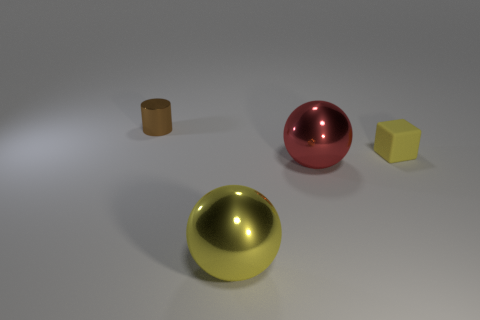Is the number of shiny objects to the left of the tiny brown metallic cylinder less than the number of big gray shiny balls?
Offer a terse response. No. There is a shiny sphere that is the same size as the red shiny thing; what color is it?
Ensure brevity in your answer.  Yellow. How many red things have the same shape as the tiny brown thing?
Your answer should be compact. 0. There is a small thing that is in front of the brown shiny cylinder; what color is it?
Give a very brief answer. Yellow. How many matte objects are either small gray cylinders or red objects?
Offer a very short reply. 0. There is a large metal thing that is the same color as the matte thing; what shape is it?
Make the answer very short. Sphere. What number of gray matte spheres have the same size as the metallic cylinder?
Make the answer very short. 0. There is a thing that is both left of the large red shiny object and behind the large yellow ball; what is its color?
Your response must be concise. Brown. What number of objects are either small blocks or tiny cylinders?
Your response must be concise. 2. What number of large things are either yellow things or cyan matte cylinders?
Make the answer very short. 1. 